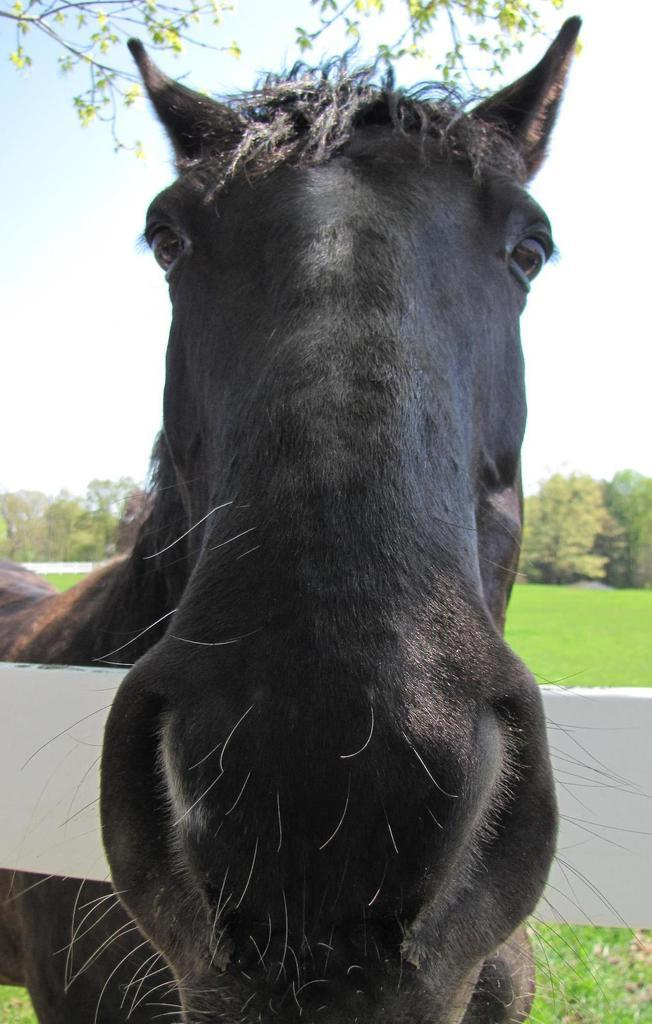What type of animal is in the image? There is a black color horse in the image. Where is the horse located in relation to the wood? The horse is standing near a white color wood. What can be seen in the background of the image? There are trees and grass on the ground in the background. How would you describe the sky in the image? The sky is blue with clouds visible. What type of stem is the horse holding in the image? There is no stem present in the image; the horse is not holding anything. 